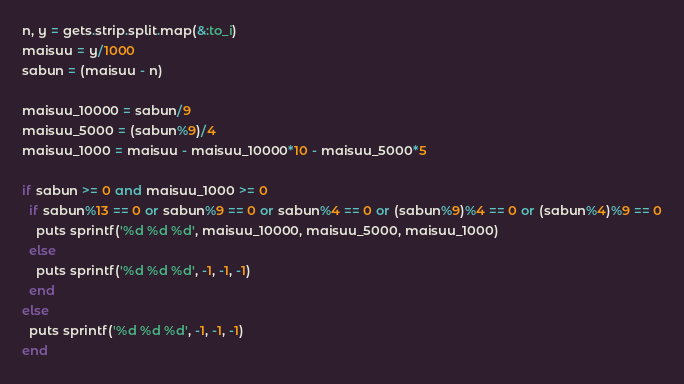<code> <loc_0><loc_0><loc_500><loc_500><_Ruby_>n, y = gets.strip.split.map(&:to_i)
maisuu = y/1000
sabun = (maisuu - n)

maisuu_10000 = sabun/9
maisuu_5000 = (sabun%9)/4
maisuu_1000 = maisuu - maisuu_10000*10 - maisuu_5000*5

if sabun >= 0 and maisuu_1000 >= 0
  if sabun%13 == 0 or sabun%9 == 0 or sabun%4 == 0 or (sabun%9)%4 == 0 or (sabun%4)%9 == 0
    puts sprintf('%d %d %d', maisuu_10000, maisuu_5000, maisuu_1000)
  else
    puts sprintf('%d %d %d', -1, -1, -1)
  end
else
  puts sprintf('%d %d %d', -1, -1, -1)
end
</code> 